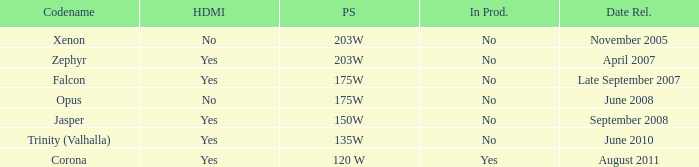Does Trinity (valhalla) have HDMI? Yes. 